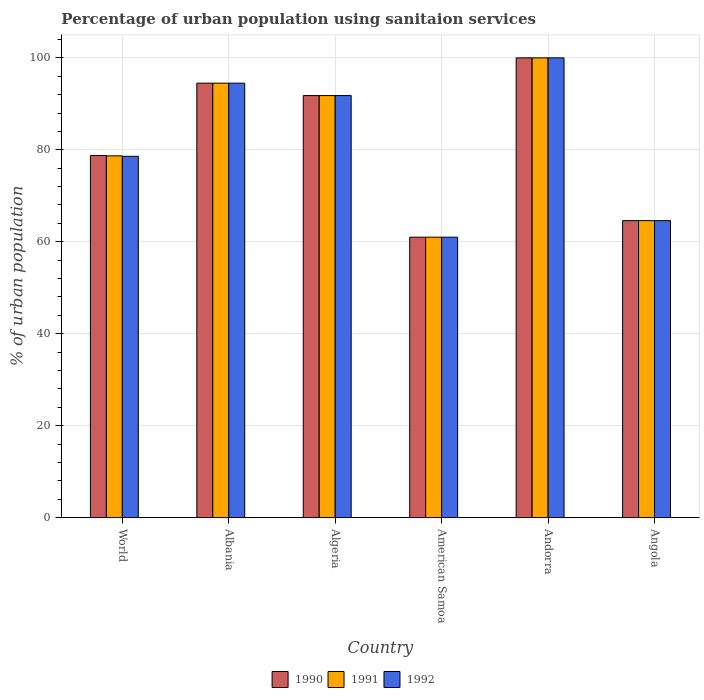How many different coloured bars are there?
Your answer should be very brief. 3. How many groups of bars are there?
Provide a short and direct response. 6. Are the number of bars on each tick of the X-axis equal?
Give a very brief answer. Yes. What is the label of the 5th group of bars from the left?
Make the answer very short. Andorra. In how many cases, is the number of bars for a given country not equal to the number of legend labels?
Make the answer very short. 0. What is the percentage of urban population using sanitaion services in 1991 in World?
Offer a terse response. 78.69. Across all countries, what is the maximum percentage of urban population using sanitaion services in 1990?
Provide a short and direct response. 100. In which country was the percentage of urban population using sanitaion services in 1991 maximum?
Offer a terse response. Andorra. In which country was the percentage of urban population using sanitaion services in 1990 minimum?
Give a very brief answer. American Samoa. What is the total percentage of urban population using sanitaion services in 1991 in the graph?
Provide a short and direct response. 490.59. What is the difference between the percentage of urban population using sanitaion services in 1992 in American Samoa and that in Andorra?
Give a very brief answer. -39. What is the difference between the percentage of urban population using sanitaion services in 1990 in World and the percentage of urban population using sanitaion services in 1991 in Albania?
Provide a succinct answer. -15.74. What is the average percentage of urban population using sanitaion services in 1992 per country?
Provide a short and direct response. 81.75. In how many countries, is the percentage of urban population using sanitaion services in 1991 greater than 96 %?
Your answer should be very brief. 1. What is the ratio of the percentage of urban population using sanitaion services in 1990 in American Samoa to that in Andorra?
Offer a very short reply. 0.61. Is the percentage of urban population using sanitaion services in 1990 in American Samoa less than that in Angola?
Provide a succinct answer. Yes. What is the difference between the highest and the second highest percentage of urban population using sanitaion services in 1991?
Your answer should be compact. -8.2. What is the difference between the highest and the lowest percentage of urban population using sanitaion services in 1992?
Ensure brevity in your answer.  39. In how many countries, is the percentage of urban population using sanitaion services in 1992 greater than the average percentage of urban population using sanitaion services in 1992 taken over all countries?
Your answer should be very brief. 3. What does the 2nd bar from the left in World represents?
Provide a succinct answer. 1991. What does the 3rd bar from the right in American Samoa represents?
Give a very brief answer. 1990. Is it the case that in every country, the sum of the percentage of urban population using sanitaion services in 1990 and percentage of urban population using sanitaion services in 1992 is greater than the percentage of urban population using sanitaion services in 1991?
Your answer should be very brief. Yes. How many bars are there?
Your response must be concise. 18. Are all the bars in the graph horizontal?
Offer a terse response. No. What is the difference between two consecutive major ticks on the Y-axis?
Offer a very short reply. 20. Does the graph contain grids?
Provide a succinct answer. Yes. How many legend labels are there?
Give a very brief answer. 3. How are the legend labels stacked?
Offer a very short reply. Horizontal. What is the title of the graph?
Provide a succinct answer. Percentage of urban population using sanitaion services. What is the label or title of the X-axis?
Provide a short and direct response. Country. What is the label or title of the Y-axis?
Provide a short and direct response. % of urban population. What is the % of urban population in 1990 in World?
Give a very brief answer. 78.76. What is the % of urban population of 1991 in World?
Offer a very short reply. 78.69. What is the % of urban population in 1992 in World?
Provide a short and direct response. 78.59. What is the % of urban population of 1990 in Albania?
Provide a short and direct response. 94.5. What is the % of urban population of 1991 in Albania?
Provide a short and direct response. 94.5. What is the % of urban population of 1992 in Albania?
Give a very brief answer. 94.5. What is the % of urban population in 1990 in Algeria?
Provide a succinct answer. 91.8. What is the % of urban population in 1991 in Algeria?
Provide a succinct answer. 91.8. What is the % of urban population of 1992 in Algeria?
Make the answer very short. 91.8. What is the % of urban population in 1990 in American Samoa?
Make the answer very short. 61. What is the % of urban population of 1991 in American Samoa?
Keep it short and to the point. 61. What is the % of urban population of 1991 in Andorra?
Your answer should be very brief. 100. What is the % of urban population of 1992 in Andorra?
Provide a succinct answer. 100. What is the % of urban population in 1990 in Angola?
Ensure brevity in your answer.  64.6. What is the % of urban population in 1991 in Angola?
Provide a short and direct response. 64.6. What is the % of urban population in 1992 in Angola?
Your response must be concise. 64.6. Across all countries, what is the maximum % of urban population in 1991?
Make the answer very short. 100. Across all countries, what is the minimum % of urban population in 1992?
Your answer should be compact. 61. What is the total % of urban population of 1990 in the graph?
Keep it short and to the point. 490.66. What is the total % of urban population of 1991 in the graph?
Keep it short and to the point. 490.59. What is the total % of urban population of 1992 in the graph?
Provide a succinct answer. 490.49. What is the difference between the % of urban population of 1990 in World and that in Albania?
Your answer should be compact. -15.74. What is the difference between the % of urban population in 1991 in World and that in Albania?
Your answer should be very brief. -15.81. What is the difference between the % of urban population in 1992 in World and that in Albania?
Make the answer very short. -15.91. What is the difference between the % of urban population in 1990 in World and that in Algeria?
Your answer should be compact. -13.04. What is the difference between the % of urban population in 1991 in World and that in Algeria?
Offer a terse response. -13.11. What is the difference between the % of urban population of 1992 in World and that in Algeria?
Offer a very short reply. -13.21. What is the difference between the % of urban population in 1990 in World and that in American Samoa?
Offer a very short reply. 17.76. What is the difference between the % of urban population of 1991 in World and that in American Samoa?
Keep it short and to the point. 17.69. What is the difference between the % of urban population in 1992 in World and that in American Samoa?
Make the answer very short. 17.59. What is the difference between the % of urban population of 1990 in World and that in Andorra?
Make the answer very short. -21.24. What is the difference between the % of urban population in 1991 in World and that in Andorra?
Your response must be concise. -21.31. What is the difference between the % of urban population in 1992 in World and that in Andorra?
Offer a very short reply. -21.41. What is the difference between the % of urban population of 1990 in World and that in Angola?
Give a very brief answer. 14.16. What is the difference between the % of urban population in 1991 in World and that in Angola?
Keep it short and to the point. 14.09. What is the difference between the % of urban population of 1992 in World and that in Angola?
Give a very brief answer. 13.99. What is the difference between the % of urban population in 1991 in Albania and that in Algeria?
Your response must be concise. 2.7. What is the difference between the % of urban population in 1992 in Albania and that in Algeria?
Ensure brevity in your answer.  2.7. What is the difference between the % of urban population in 1990 in Albania and that in American Samoa?
Make the answer very short. 33.5. What is the difference between the % of urban population in 1991 in Albania and that in American Samoa?
Your answer should be very brief. 33.5. What is the difference between the % of urban population of 1992 in Albania and that in American Samoa?
Keep it short and to the point. 33.5. What is the difference between the % of urban population of 1990 in Albania and that in Angola?
Provide a short and direct response. 29.9. What is the difference between the % of urban population of 1991 in Albania and that in Angola?
Give a very brief answer. 29.9. What is the difference between the % of urban population in 1992 in Albania and that in Angola?
Offer a terse response. 29.9. What is the difference between the % of urban population in 1990 in Algeria and that in American Samoa?
Ensure brevity in your answer.  30.8. What is the difference between the % of urban population in 1991 in Algeria and that in American Samoa?
Make the answer very short. 30.8. What is the difference between the % of urban population of 1992 in Algeria and that in American Samoa?
Your answer should be very brief. 30.8. What is the difference between the % of urban population in 1991 in Algeria and that in Andorra?
Your response must be concise. -8.2. What is the difference between the % of urban population of 1990 in Algeria and that in Angola?
Keep it short and to the point. 27.2. What is the difference between the % of urban population of 1991 in Algeria and that in Angola?
Your answer should be compact. 27.2. What is the difference between the % of urban population of 1992 in Algeria and that in Angola?
Your answer should be very brief. 27.2. What is the difference between the % of urban population in 1990 in American Samoa and that in Andorra?
Give a very brief answer. -39. What is the difference between the % of urban population of 1991 in American Samoa and that in Andorra?
Your answer should be compact. -39. What is the difference between the % of urban population in 1992 in American Samoa and that in Andorra?
Your answer should be very brief. -39. What is the difference between the % of urban population in 1992 in American Samoa and that in Angola?
Keep it short and to the point. -3.6. What is the difference between the % of urban population in 1990 in Andorra and that in Angola?
Your answer should be compact. 35.4. What is the difference between the % of urban population in 1991 in Andorra and that in Angola?
Ensure brevity in your answer.  35.4. What is the difference between the % of urban population in 1992 in Andorra and that in Angola?
Your answer should be very brief. 35.4. What is the difference between the % of urban population of 1990 in World and the % of urban population of 1991 in Albania?
Offer a terse response. -15.74. What is the difference between the % of urban population in 1990 in World and the % of urban population in 1992 in Albania?
Provide a succinct answer. -15.74. What is the difference between the % of urban population in 1991 in World and the % of urban population in 1992 in Albania?
Offer a very short reply. -15.81. What is the difference between the % of urban population of 1990 in World and the % of urban population of 1991 in Algeria?
Keep it short and to the point. -13.04. What is the difference between the % of urban population in 1990 in World and the % of urban population in 1992 in Algeria?
Provide a succinct answer. -13.04. What is the difference between the % of urban population in 1991 in World and the % of urban population in 1992 in Algeria?
Offer a terse response. -13.11. What is the difference between the % of urban population of 1990 in World and the % of urban population of 1991 in American Samoa?
Your answer should be very brief. 17.76. What is the difference between the % of urban population in 1990 in World and the % of urban population in 1992 in American Samoa?
Offer a very short reply. 17.76. What is the difference between the % of urban population in 1991 in World and the % of urban population in 1992 in American Samoa?
Your response must be concise. 17.69. What is the difference between the % of urban population of 1990 in World and the % of urban population of 1991 in Andorra?
Your answer should be very brief. -21.24. What is the difference between the % of urban population in 1990 in World and the % of urban population in 1992 in Andorra?
Make the answer very short. -21.24. What is the difference between the % of urban population in 1991 in World and the % of urban population in 1992 in Andorra?
Keep it short and to the point. -21.31. What is the difference between the % of urban population of 1990 in World and the % of urban population of 1991 in Angola?
Give a very brief answer. 14.16. What is the difference between the % of urban population of 1990 in World and the % of urban population of 1992 in Angola?
Provide a succinct answer. 14.16. What is the difference between the % of urban population in 1991 in World and the % of urban population in 1992 in Angola?
Offer a very short reply. 14.09. What is the difference between the % of urban population of 1991 in Albania and the % of urban population of 1992 in Algeria?
Provide a short and direct response. 2.7. What is the difference between the % of urban population in 1990 in Albania and the % of urban population in 1991 in American Samoa?
Ensure brevity in your answer.  33.5. What is the difference between the % of urban population of 1990 in Albania and the % of urban population of 1992 in American Samoa?
Give a very brief answer. 33.5. What is the difference between the % of urban population in 1991 in Albania and the % of urban population in 1992 in American Samoa?
Your response must be concise. 33.5. What is the difference between the % of urban population of 1990 in Albania and the % of urban population of 1991 in Andorra?
Your answer should be very brief. -5.5. What is the difference between the % of urban population in 1990 in Albania and the % of urban population in 1992 in Andorra?
Make the answer very short. -5.5. What is the difference between the % of urban population of 1991 in Albania and the % of urban population of 1992 in Andorra?
Provide a succinct answer. -5.5. What is the difference between the % of urban population of 1990 in Albania and the % of urban population of 1991 in Angola?
Provide a short and direct response. 29.9. What is the difference between the % of urban population in 1990 in Albania and the % of urban population in 1992 in Angola?
Your answer should be compact. 29.9. What is the difference between the % of urban population of 1991 in Albania and the % of urban population of 1992 in Angola?
Your response must be concise. 29.9. What is the difference between the % of urban population of 1990 in Algeria and the % of urban population of 1991 in American Samoa?
Ensure brevity in your answer.  30.8. What is the difference between the % of urban population in 1990 in Algeria and the % of urban population in 1992 in American Samoa?
Provide a short and direct response. 30.8. What is the difference between the % of urban population of 1991 in Algeria and the % of urban population of 1992 in American Samoa?
Make the answer very short. 30.8. What is the difference between the % of urban population in 1990 in Algeria and the % of urban population in 1991 in Angola?
Offer a terse response. 27.2. What is the difference between the % of urban population of 1990 in Algeria and the % of urban population of 1992 in Angola?
Your answer should be compact. 27.2. What is the difference between the % of urban population of 1991 in Algeria and the % of urban population of 1992 in Angola?
Provide a succinct answer. 27.2. What is the difference between the % of urban population in 1990 in American Samoa and the % of urban population in 1991 in Andorra?
Make the answer very short. -39. What is the difference between the % of urban population of 1990 in American Samoa and the % of urban population of 1992 in Andorra?
Keep it short and to the point. -39. What is the difference between the % of urban population in 1991 in American Samoa and the % of urban population in 1992 in Andorra?
Offer a very short reply. -39. What is the difference between the % of urban population in 1990 in American Samoa and the % of urban population in 1991 in Angola?
Your response must be concise. -3.6. What is the difference between the % of urban population in 1990 in American Samoa and the % of urban population in 1992 in Angola?
Give a very brief answer. -3.6. What is the difference between the % of urban population of 1991 in American Samoa and the % of urban population of 1992 in Angola?
Keep it short and to the point. -3.6. What is the difference between the % of urban population in 1990 in Andorra and the % of urban population in 1991 in Angola?
Your answer should be very brief. 35.4. What is the difference between the % of urban population in 1990 in Andorra and the % of urban population in 1992 in Angola?
Your answer should be very brief. 35.4. What is the difference between the % of urban population in 1991 in Andorra and the % of urban population in 1992 in Angola?
Your answer should be compact. 35.4. What is the average % of urban population in 1990 per country?
Provide a succinct answer. 81.78. What is the average % of urban population of 1991 per country?
Keep it short and to the point. 81.76. What is the average % of urban population of 1992 per country?
Provide a succinct answer. 81.75. What is the difference between the % of urban population of 1990 and % of urban population of 1991 in World?
Offer a very short reply. 0.07. What is the difference between the % of urban population in 1990 and % of urban population in 1992 in World?
Your answer should be compact. 0.17. What is the difference between the % of urban population in 1991 and % of urban population in 1992 in World?
Give a very brief answer. 0.1. What is the difference between the % of urban population in 1990 and % of urban population in 1991 in Algeria?
Give a very brief answer. 0. What is the difference between the % of urban population in 1991 and % of urban population in 1992 in Algeria?
Offer a very short reply. 0. What is the difference between the % of urban population of 1990 and % of urban population of 1991 in American Samoa?
Keep it short and to the point. 0. What is the difference between the % of urban population of 1990 and % of urban population of 1992 in American Samoa?
Offer a very short reply. 0. What is the difference between the % of urban population of 1991 and % of urban population of 1992 in Andorra?
Your response must be concise. 0. What is the difference between the % of urban population in 1990 and % of urban population in 1992 in Angola?
Give a very brief answer. 0. What is the difference between the % of urban population of 1991 and % of urban population of 1992 in Angola?
Keep it short and to the point. 0. What is the ratio of the % of urban population in 1990 in World to that in Albania?
Offer a terse response. 0.83. What is the ratio of the % of urban population in 1991 in World to that in Albania?
Your answer should be very brief. 0.83. What is the ratio of the % of urban population of 1992 in World to that in Albania?
Offer a very short reply. 0.83. What is the ratio of the % of urban population of 1990 in World to that in Algeria?
Make the answer very short. 0.86. What is the ratio of the % of urban population in 1991 in World to that in Algeria?
Your answer should be very brief. 0.86. What is the ratio of the % of urban population in 1992 in World to that in Algeria?
Keep it short and to the point. 0.86. What is the ratio of the % of urban population in 1990 in World to that in American Samoa?
Your answer should be compact. 1.29. What is the ratio of the % of urban population of 1991 in World to that in American Samoa?
Your answer should be compact. 1.29. What is the ratio of the % of urban population of 1992 in World to that in American Samoa?
Your answer should be compact. 1.29. What is the ratio of the % of urban population in 1990 in World to that in Andorra?
Make the answer very short. 0.79. What is the ratio of the % of urban population of 1991 in World to that in Andorra?
Give a very brief answer. 0.79. What is the ratio of the % of urban population of 1992 in World to that in Andorra?
Offer a very short reply. 0.79. What is the ratio of the % of urban population in 1990 in World to that in Angola?
Your answer should be very brief. 1.22. What is the ratio of the % of urban population in 1991 in World to that in Angola?
Ensure brevity in your answer.  1.22. What is the ratio of the % of urban population of 1992 in World to that in Angola?
Offer a terse response. 1.22. What is the ratio of the % of urban population of 1990 in Albania to that in Algeria?
Offer a terse response. 1.03. What is the ratio of the % of urban population in 1991 in Albania to that in Algeria?
Offer a terse response. 1.03. What is the ratio of the % of urban population of 1992 in Albania to that in Algeria?
Your answer should be compact. 1.03. What is the ratio of the % of urban population of 1990 in Albania to that in American Samoa?
Keep it short and to the point. 1.55. What is the ratio of the % of urban population in 1991 in Albania to that in American Samoa?
Keep it short and to the point. 1.55. What is the ratio of the % of urban population of 1992 in Albania to that in American Samoa?
Keep it short and to the point. 1.55. What is the ratio of the % of urban population in 1990 in Albania to that in Andorra?
Offer a very short reply. 0.94. What is the ratio of the % of urban population in 1991 in Albania to that in Andorra?
Your response must be concise. 0.94. What is the ratio of the % of urban population of 1992 in Albania to that in Andorra?
Keep it short and to the point. 0.94. What is the ratio of the % of urban population of 1990 in Albania to that in Angola?
Give a very brief answer. 1.46. What is the ratio of the % of urban population of 1991 in Albania to that in Angola?
Your answer should be very brief. 1.46. What is the ratio of the % of urban population of 1992 in Albania to that in Angola?
Make the answer very short. 1.46. What is the ratio of the % of urban population of 1990 in Algeria to that in American Samoa?
Ensure brevity in your answer.  1.5. What is the ratio of the % of urban population of 1991 in Algeria to that in American Samoa?
Keep it short and to the point. 1.5. What is the ratio of the % of urban population in 1992 in Algeria to that in American Samoa?
Give a very brief answer. 1.5. What is the ratio of the % of urban population in 1990 in Algeria to that in Andorra?
Make the answer very short. 0.92. What is the ratio of the % of urban population in 1991 in Algeria to that in Andorra?
Ensure brevity in your answer.  0.92. What is the ratio of the % of urban population of 1992 in Algeria to that in Andorra?
Your response must be concise. 0.92. What is the ratio of the % of urban population of 1990 in Algeria to that in Angola?
Your answer should be compact. 1.42. What is the ratio of the % of urban population in 1991 in Algeria to that in Angola?
Offer a terse response. 1.42. What is the ratio of the % of urban population of 1992 in Algeria to that in Angola?
Provide a succinct answer. 1.42. What is the ratio of the % of urban population in 1990 in American Samoa to that in Andorra?
Offer a very short reply. 0.61. What is the ratio of the % of urban population of 1991 in American Samoa to that in Andorra?
Ensure brevity in your answer.  0.61. What is the ratio of the % of urban population of 1992 in American Samoa to that in Andorra?
Your response must be concise. 0.61. What is the ratio of the % of urban population in 1990 in American Samoa to that in Angola?
Your answer should be very brief. 0.94. What is the ratio of the % of urban population in 1991 in American Samoa to that in Angola?
Your response must be concise. 0.94. What is the ratio of the % of urban population of 1992 in American Samoa to that in Angola?
Provide a succinct answer. 0.94. What is the ratio of the % of urban population in 1990 in Andorra to that in Angola?
Make the answer very short. 1.55. What is the ratio of the % of urban population in 1991 in Andorra to that in Angola?
Make the answer very short. 1.55. What is the ratio of the % of urban population of 1992 in Andorra to that in Angola?
Ensure brevity in your answer.  1.55. What is the difference between the highest and the second highest % of urban population in 1990?
Your answer should be compact. 5.5. What is the difference between the highest and the second highest % of urban population of 1991?
Your answer should be compact. 5.5. What is the difference between the highest and the second highest % of urban population in 1992?
Your answer should be compact. 5.5. What is the difference between the highest and the lowest % of urban population in 1990?
Give a very brief answer. 39. What is the difference between the highest and the lowest % of urban population in 1992?
Offer a very short reply. 39. 